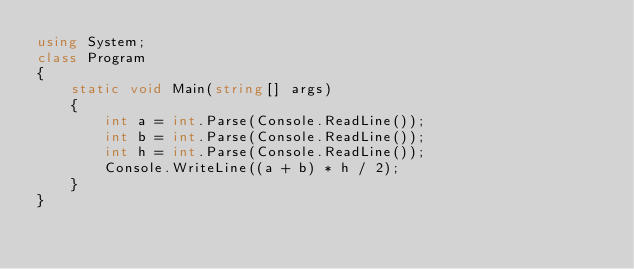Convert code to text. <code><loc_0><loc_0><loc_500><loc_500><_C#_>using System;
class Program
{
    static void Main(string[] args)
    {
        int a = int.Parse(Console.ReadLine());
        int b = int.Parse(Console.ReadLine());
        int h = int.Parse(Console.ReadLine());
        Console.WriteLine((a + b) * h / 2);
    }
}</code> 